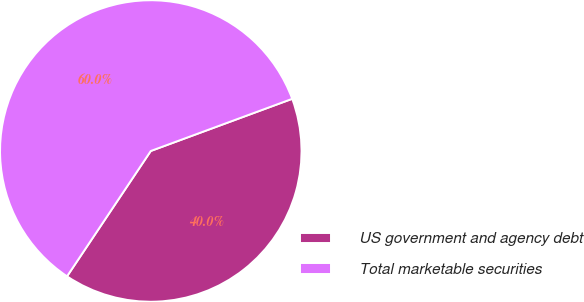<chart> <loc_0><loc_0><loc_500><loc_500><pie_chart><fcel>US government and agency debt<fcel>Total marketable securities<nl><fcel>40.0%<fcel>60.0%<nl></chart> 